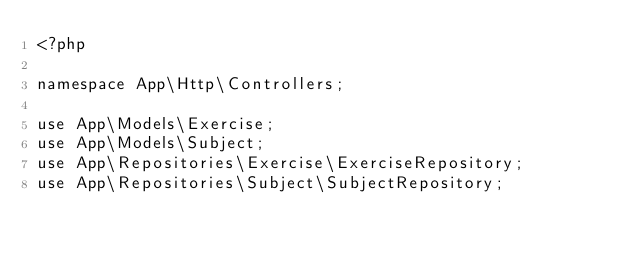Convert code to text. <code><loc_0><loc_0><loc_500><loc_500><_PHP_><?php

namespace App\Http\Controllers;

use App\Models\Exercise;
use App\Models\Subject;
use App\Repositories\Exercise\ExerciseRepository;
use App\Repositories\Subject\SubjectRepository;</code> 